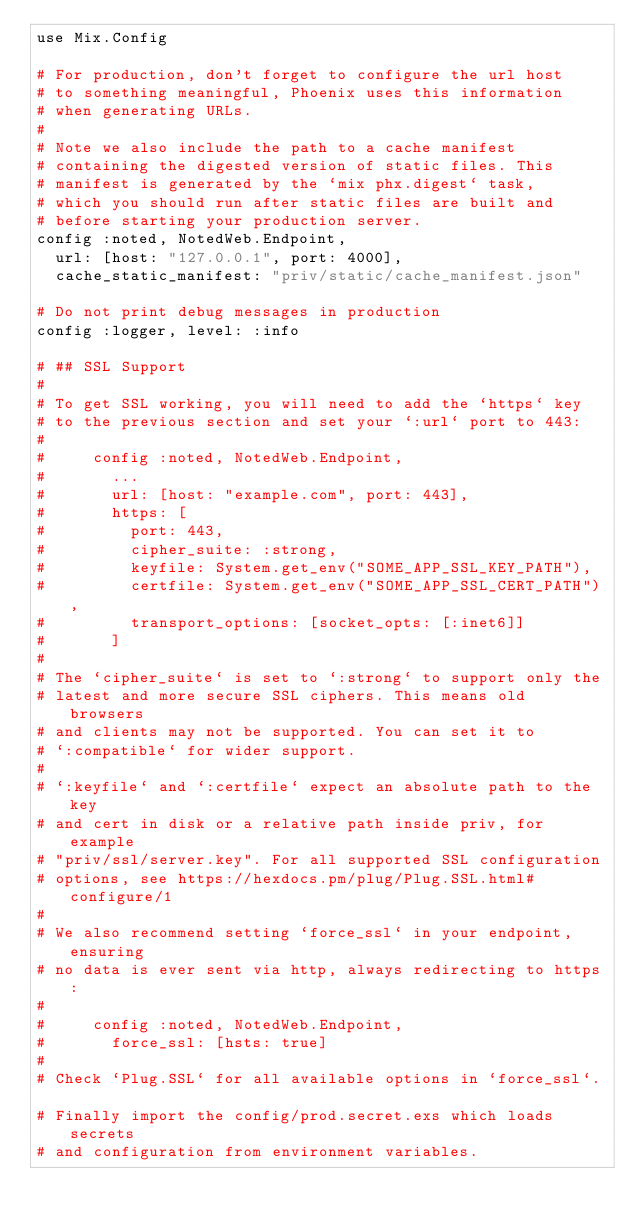Convert code to text. <code><loc_0><loc_0><loc_500><loc_500><_Elixir_>use Mix.Config

# For production, don't forget to configure the url host
# to something meaningful, Phoenix uses this information
# when generating URLs.
#
# Note we also include the path to a cache manifest
# containing the digested version of static files. This
# manifest is generated by the `mix phx.digest` task,
# which you should run after static files are built and
# before starting your production server.
config :noted, NotedWeb.Endpoint,
  url: [host: "127.0.0.1", port: 4000],
  cache_static_manifest: "priv/static/cache_manifest.json"

# Do not print debug messages in production
config :logger, level: :info

# ## SSL Support
#
# To get SSL working, you will need to add the `https` key
# to the previous section and set your `:url` port to 443:
#
#     config :noted, NotedWeb.Endpoint,
#       ...
#       url: [host: "example.com", port: 443],
#       https: [
#         port: 443,
#         cipher_suite: :strong,
#         keyfile: System.get_env("SOME_APP_SSL_KEY_PATH"),
#         certfile: System.get_env("SOME_APP_SSL_CERT_PATH"),
#         transport_options: [socket_opts: [:inet6]]
#       ]
#
# The `cipher_suite` is set to `:strong` to support only the
# latest and more secure SSL ciphers. This means old browsers
# and clients may not be supported. You can set it to
# `:compatible` for wider support.
#
# `:keyfile` and `:certfile` expect an absolute path to the key
# and cert in disk or a relative path inside priv, for example
# "priv/ssl/server.key". For all supported SSL configuration
# options, see https://hexdocs.pm/plug/Plug.SSL.html#configure/1
#
# We also recommend setting `force_ssl` in your endpoint, ensuring
# no data is ever sent via http, always redirecting to https:
#
#     config :noted, NotedWeb.Endpoint,
#       force_ssl: [hsts: true]
#
# Check `Plug.SSL` for all available options in `force_ssl`.

# Finally import the config/prod.secret.exs which loads secrets
# and configuration from environment variables.
</code> 